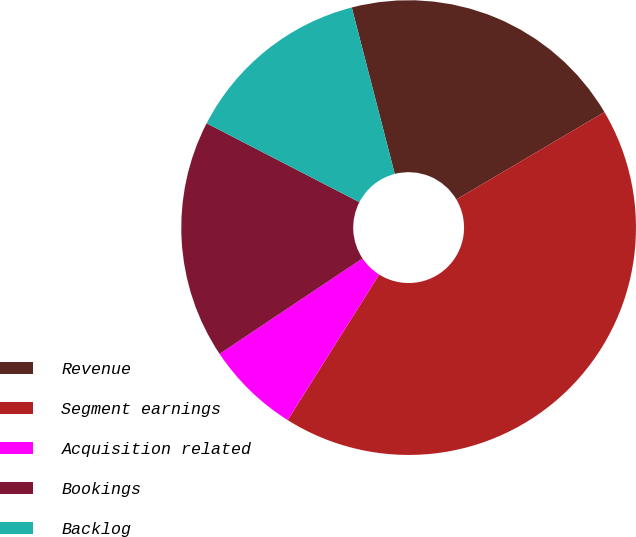<chart> <loc_0><loc_0><loc_500><loc_500><pie_chart><fcel>Revenue<fcel>Segment earnings<fcel>Acquisition related<fcel>Bookings<fcel>Backlog<nl><fcel>20.54%<fcel>42.41%<fcel>6.7%<fcel>16.96%<fcel>13.39%<nl></chart> 